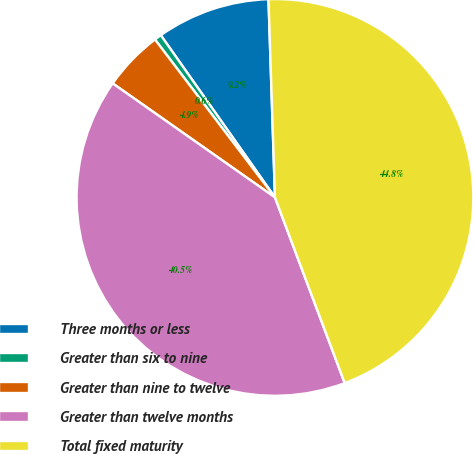Convert chart. <chart><loc_0><loc_0><loc_500><loc_500><pie_chart><fcel>Three months or less<fcel>Greater than six to nine<fcel>Greater than nine to twelve<fcel>Greater than twelve months<fcel>Total fixed maturity<nl><fcel>9.24%<fcel>0.58%<fcel>4.91%<fcel>40.47%<fcel>44.8%<nl></chart> 